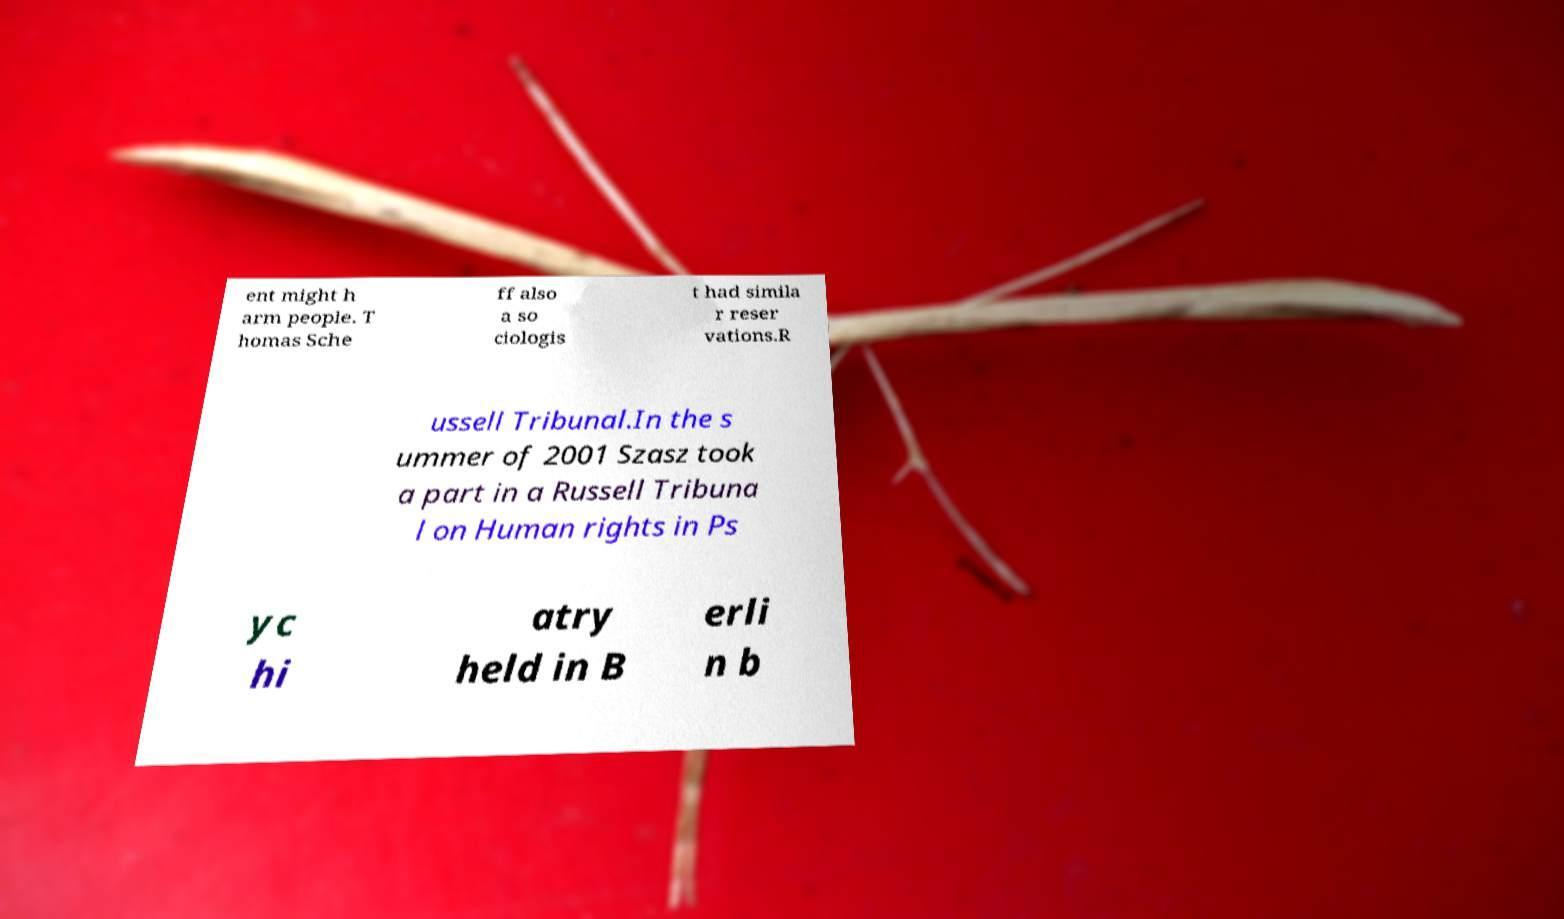Can you accurately transcribe the text from the provided image for me? ent might h arm people. T homas Sche ff also a so ciologis t had simila r reser vations.R ussell Tribunal.In the s ummer of 2001 Szasz took a part in a Russell Tribuna l on Human rights in Ps yc hi atry held in B erli n b 